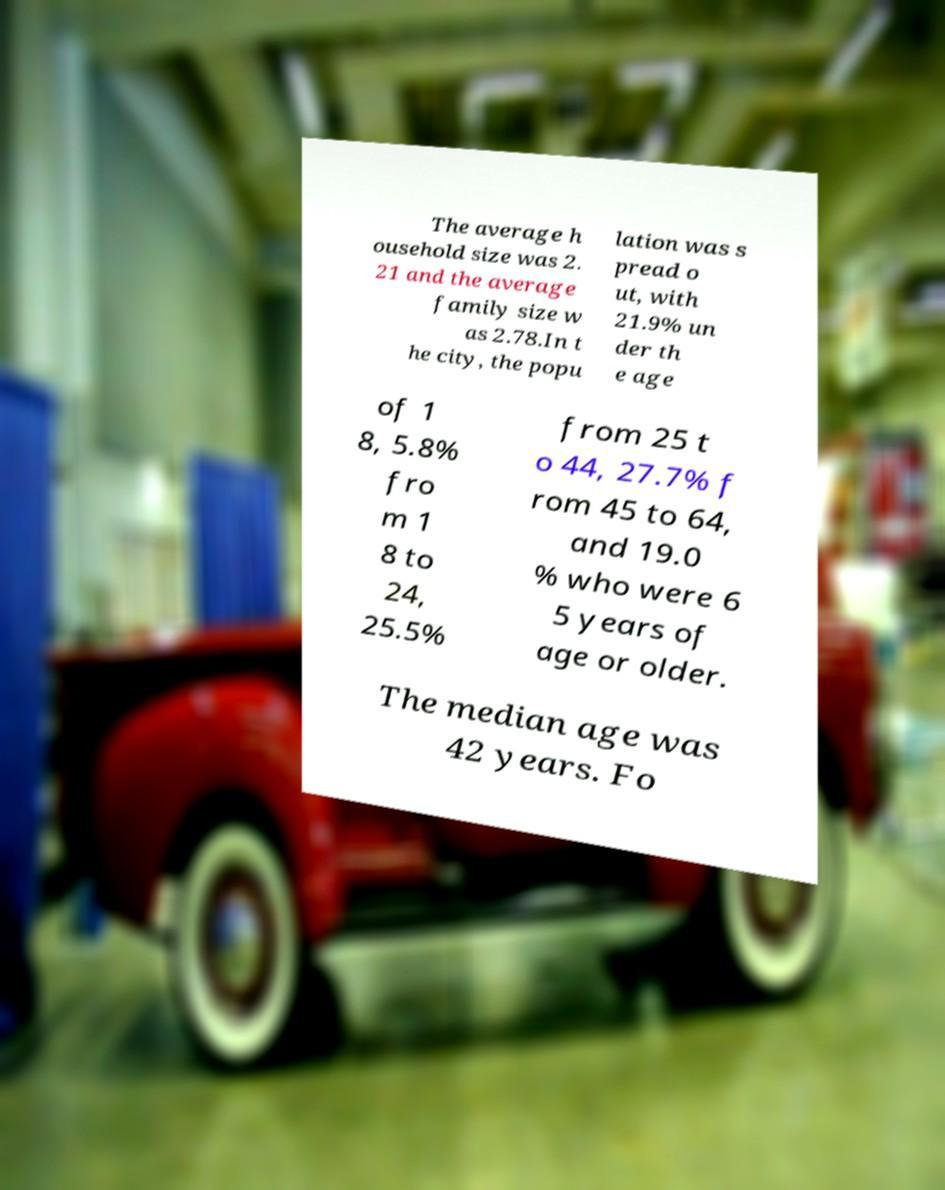There's text embedded in this image that I need extracted. Can you transcribe it verbatim? The average h ousehold size was 2. 21 and the average family size w as 2.78.In t he city, the popu lation was s pread o ut, with 21.9% un der th e age of 1 8, 5.8% fro m 1 8 to 24, 25.5% from 25 t o 44, 27.7% f rom 45 to 64, and 19.0 % who were 6 5 years of age or older. The median age was 42 years. Fo 